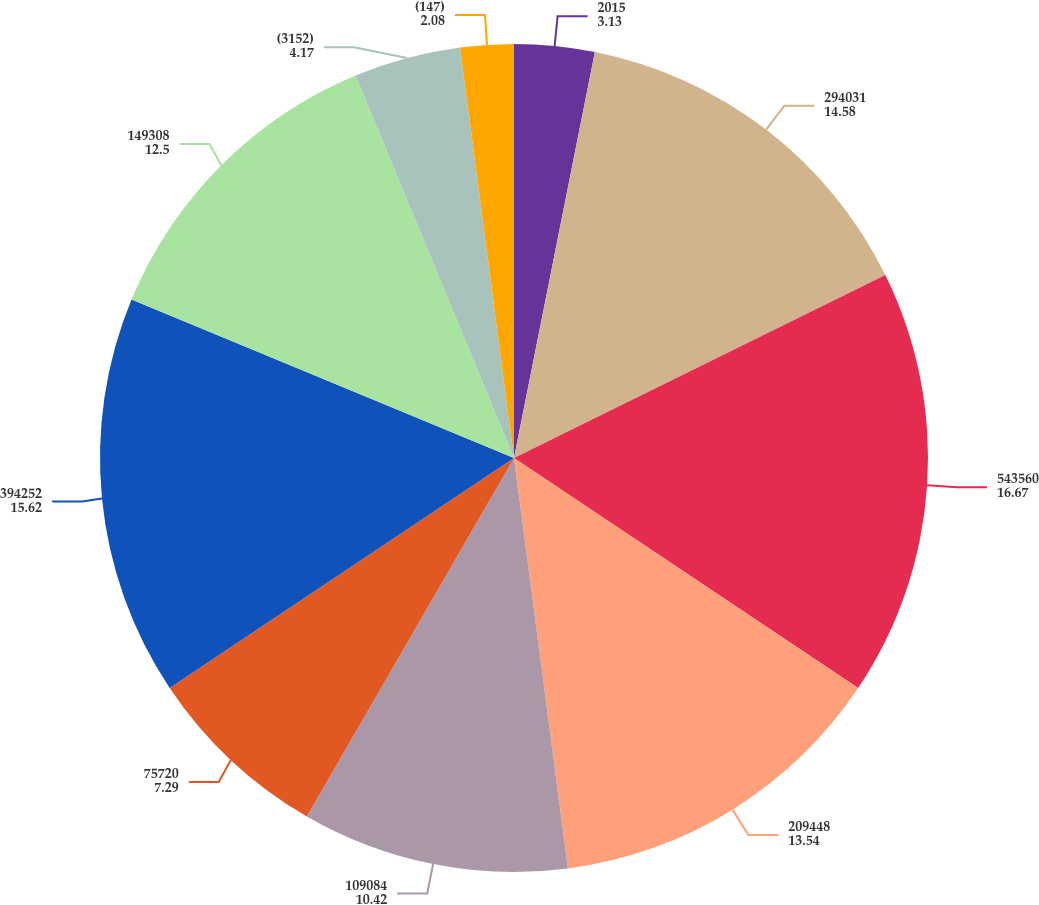<chart> <loc_0><loc_0><loc_500><loc_500><pie_chart><fcel>2015<fcel>294031<fcel>543560<fcel>209448<fcel>109084<fcel>75720<fcel>394252<fcel>149308<fcel>(3152)<fcel>(147)<nl><fcel>3.13%<fcel>14.58%<fcel>16.67%<fcel>13.54%<fcel>10.42%<fcel>7.29%<fcel>15.62%<fcel>12.5%<fcel>4.17%<fcel>2.08%<nl></chart> 